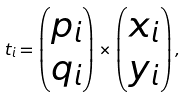<formula> <loc_0><loc_0><loc_500><loc_500>t _ { i } = \begin{pmatrix} p _ { i } \\ q _ { i } \end{pmatrix} \times \begin{pmatrix} x _ { i } \\ y _ { i } \end{pmatrix} ,</formula> 